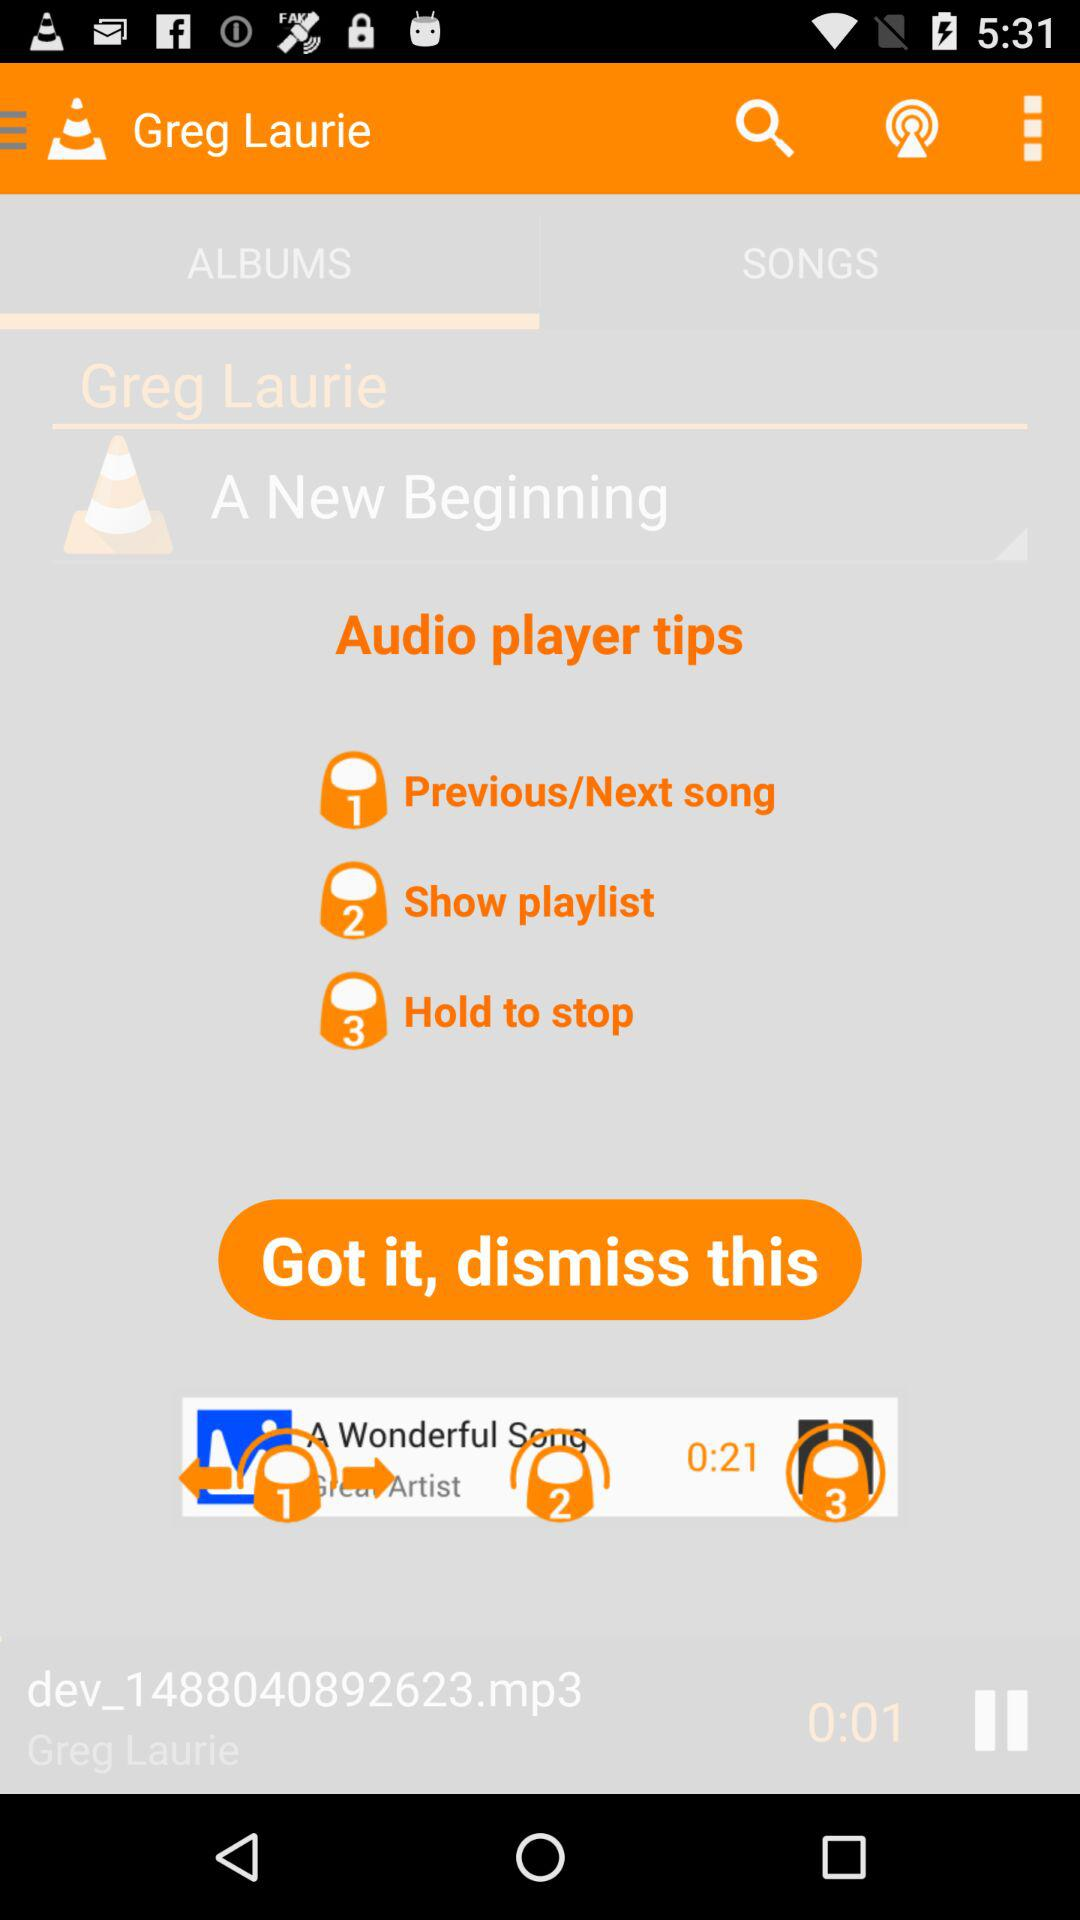Which tab am I on? You are on the "ALBUMS" tab. 